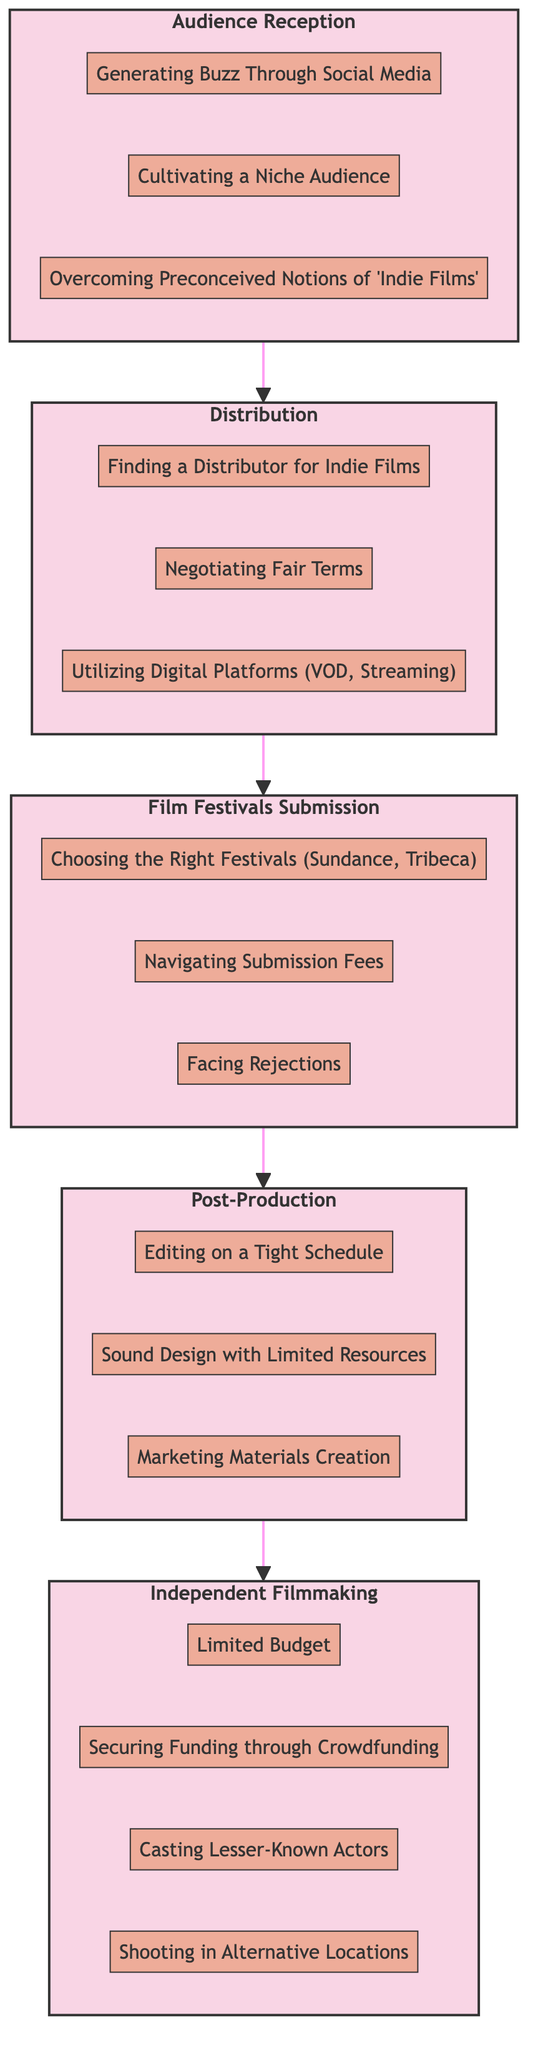What is the final stage in the journey of a lesser-known film? The diagram shows that the flow concludes with the 'Audience Reception' stage as the last node.
Answer: Audience Reception How many challenges are listed under 'Post-Production'? By counting the individual challenges listed in the 'Post-Production' subgraph, there are three specific challenges present.
Answer: 3 Which stage comes before 'Distribution'? Following the flow of the diagram from 'Audience Reception', the stage directly preceding 'Distribution' is 'Film Festivals Submission'.
Answer: Film Festivals Submission What is one challenge faced during 'Independent Filmmaking'? The 'Independent Filmmaking' subgraph contains multiple challenges, one of which is 'Limited Budget', which addresses financial constraints in this stage.
Answer: Limited Budget How many total stages are there in the film journey? By analyzing the diagram, there are five distinct stages identified throughout the journey, each represented by a subgraph.
Answer: 5 What challenge involves promoting the film to audiences? The challenge 'Generating Buzz Through Social Media' is specifically focused on promoting the film and connecting with audiences.
Answer: Generating Buzz Through Social Media Which stage must a film undergo after post-production? According to the diagram, after completing 'Post-Production', the film progresses to the 'Film Festivals Submission' stage.
Answer: Film Festivals Submission What is the main focus of the 'Distribution' stage? The 'Distribution' stage is primarily concerned with 'Finding a Distributor for Indie Films', which is critical for getting the film to audiences.
Answer: Finding a Distributor for Indie Films What is a common challenge during the film festival submission process? A notable challenge listed under the 'Film Festivals Submission' stage is 'Facing Rejections', which highlights the competitive nature of film festivals.
Answer: Facing Rejections 